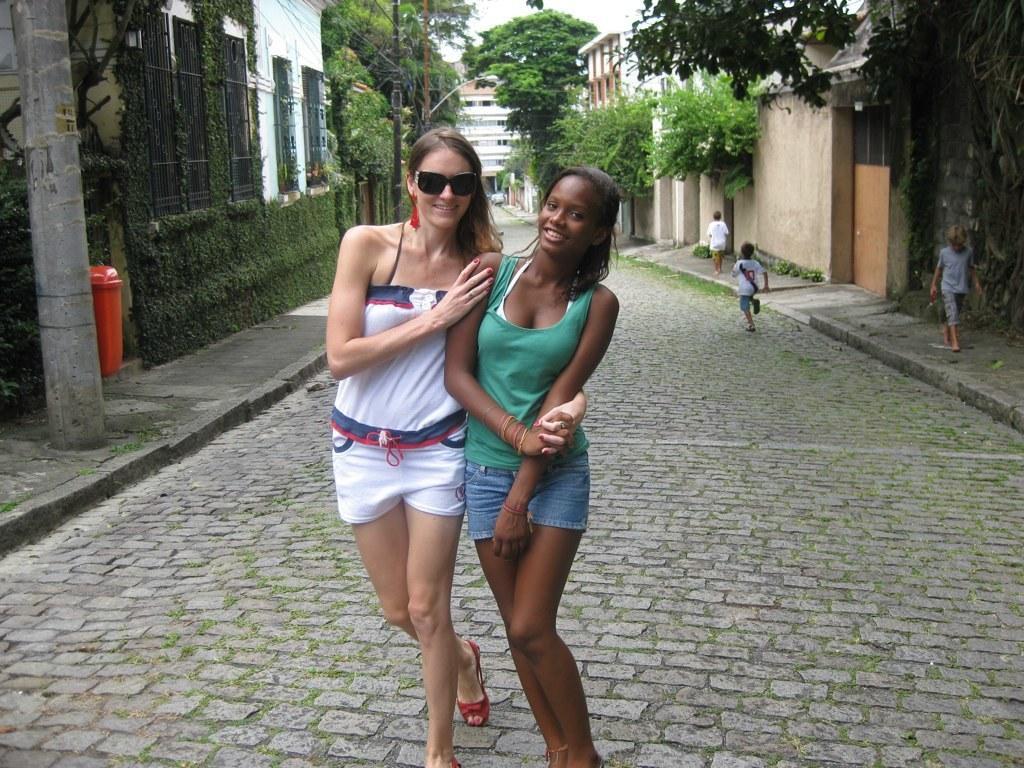Could you give a brief overview of what you see in this image? In the center of the image we can see two women standing on the ground. One woman is wearing goggles. To the right side of the image we can see three kids standing on the path. In the background, we can see a group of buildings, trees and the sky. 